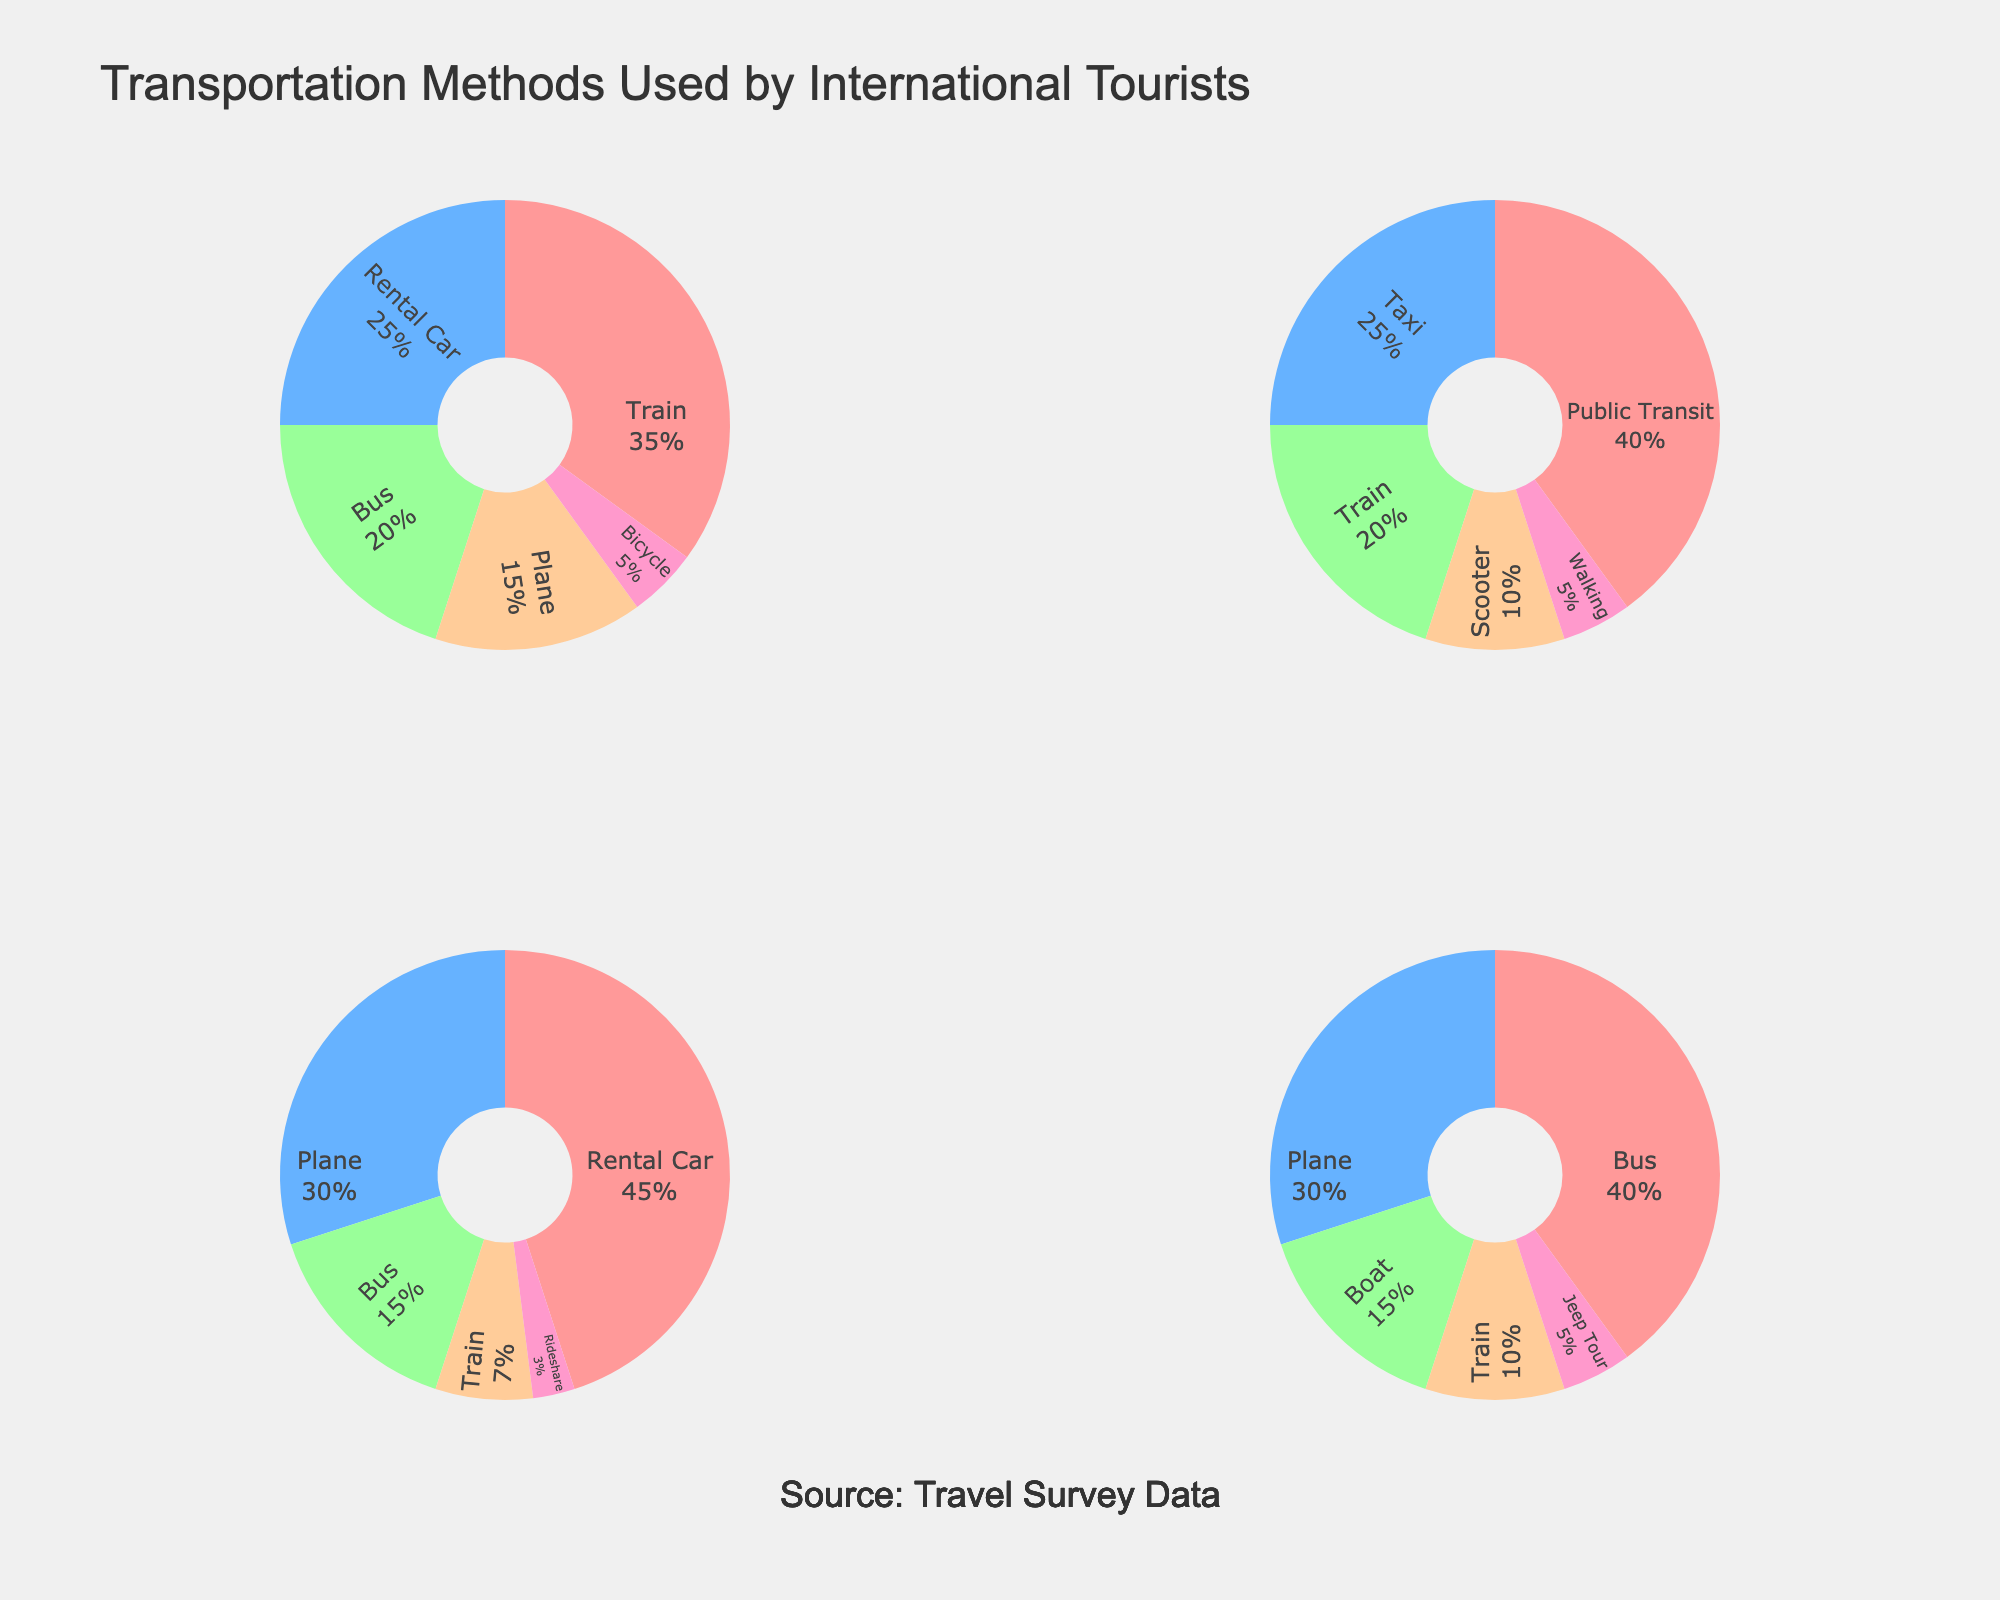What's the most common transportation method used by tourists in Europe? In the pie chart for Europe, the largest slice represents the transportation method with the highest percentage. The 'Train' method has the largest representation at 35%.
Answer: Train Which transportation method is used by 25% of tourists in North America? By referring to the North American pie chart, the slice representing 'Rental Car' has a 45% label. The next closest slice, 'Plane,' is 30%. 'Bus' follows at 15%, and 'Train' is at 7%. There is no 25% representation.
Answer: None How much more popular is the 'Rental Car' method than 'Bus' in North America? In the North American pie chart, 'Rental Car' is at 45%, and 'Bus' is at 15%. The difference is 45% - 15% = 30%.
Answer: 30% What percentage of tourists use two-wheeled transportation methods in Asia? Adding up the percentages for 'Scooter' (10%) and 'Train' (20%) from the Asian pie chart, we get 10% + 20% = 30%.
Answer: 30% Which region has 'Bus' as the most popular transportation method? The region where 'Bus' is the largest slice in the pie chart indicating it as the most common transportation method is South America with 'Bus' at 40%.
Answer: South America If a tourist in Asia does not use Public Transit, what is the probability they will use a Taxi? Excluding Public Transit (40%), the remaining percentage for other methods is 60% (100% - 40%). The slice for 'Taxi' is 25%, so the probability is 25% / 60% = 41.67%.
Answer: 41.67% Which region has the least usage of planes as a transportation method? Observing the slices representing 'Plane' usage, Europe has the smallest at 15%.
Answer: Europe How many regions have multiple transportation methods each above 20% usage? Europe has 'Train' (35%), 'Rental Car' (25%), and 'Bus' (20%). Asia has 'Public Transit' (40%) and 'Taxi' (25%). North America has 'Rental Car' (45%) and 'Plane' (30%). South America has 'Bus' (40%) and 'Plane' (30%). Each of these regions qualifies, so four regions.
Answer: 4 What's the combined percentage of tourists using either a Train or Bus in Europe? From the European pie chart, 'Train' is 35%, and 'Bus' is 20%. Adding them gives 35% + 20% = 55%.
Answer: 55% Which region's transportation preferences are the most diverse, having the most transportation methods listed and none exceeding 50% usage? In the pie charts, South America has five different transportation methods listed (Bus, Plane, Boat, Train, Jeep Tour). None of them exceed 50%.
Answer: South America 